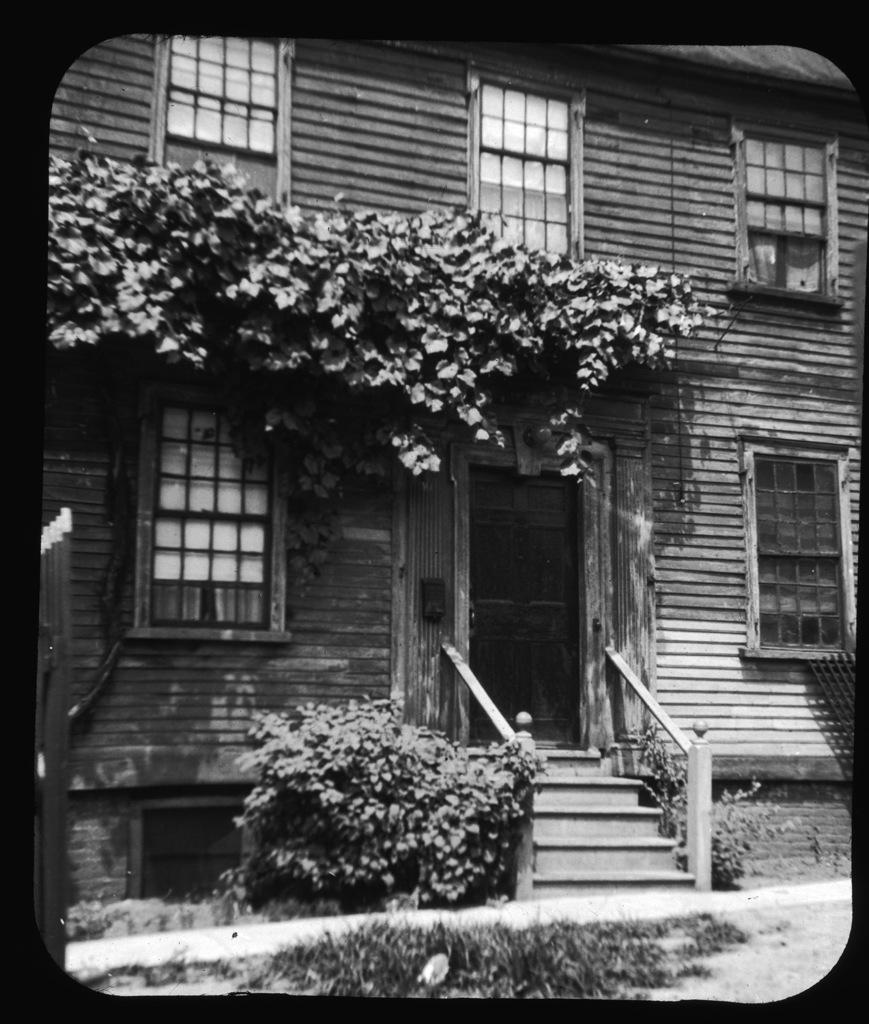What type of structure is in the picture? There is a building in the picture. What features can be seen on the building? The building has windows and doors. What else is present in the picture besides the building? There are plants and stairs in the picture. How many sheep are visible in the picture? There are no sheep present in the picture. What type of produce can be seen in the picture? There is no produce visible in the picture. 